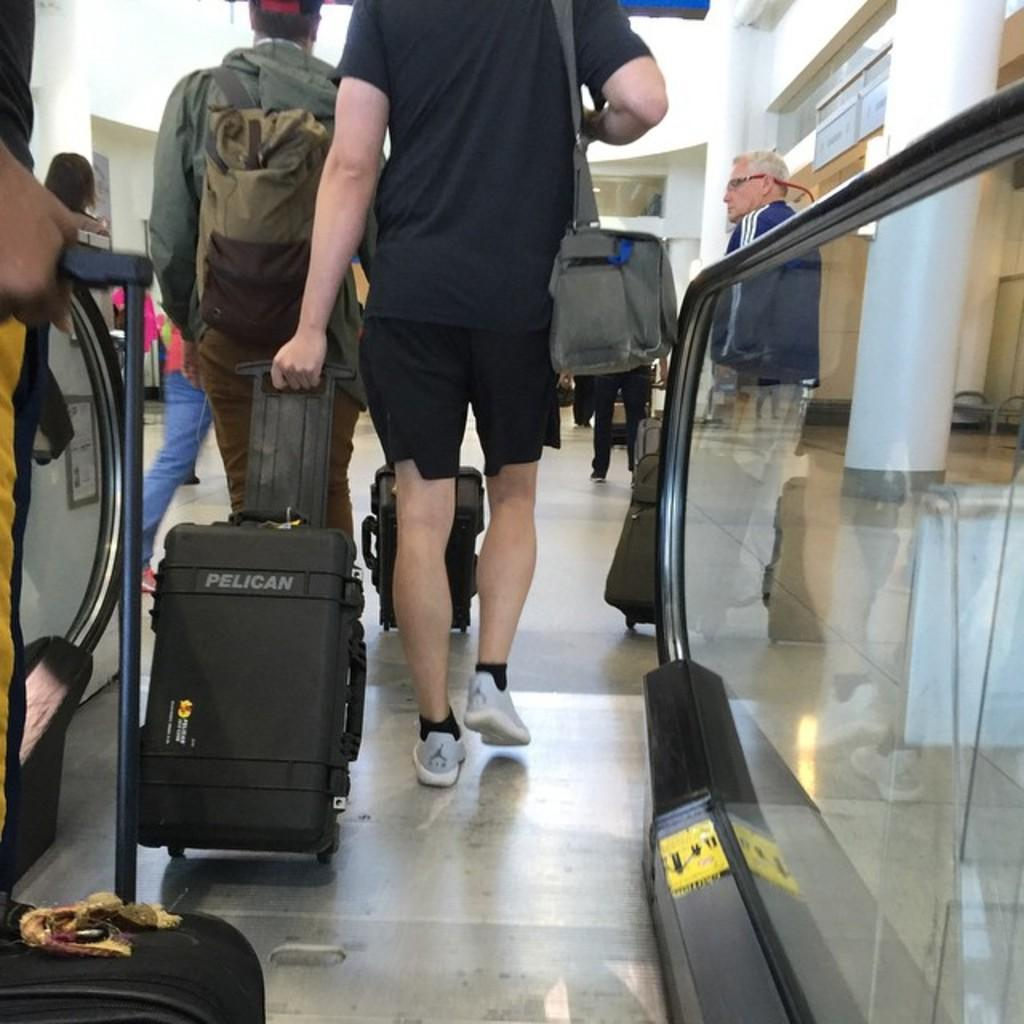How many persons are in the image? There are persons in the image, but the exact number is not specified. What are the persons doing in the image? The persons are walking, as indicated by leg movement. What are the persons holding in the image? The persons are holding luggage and a wire bag. What is the purpose of the wire bag? The purpose of the wire bag is not specified, but it is being held by the persons. What is the stationary object in the image? There is a pillar in the image. What type of fan is visible in the image? There is no fan present in the image. What time of day is it in the image? The time of day is not specified in the image. 